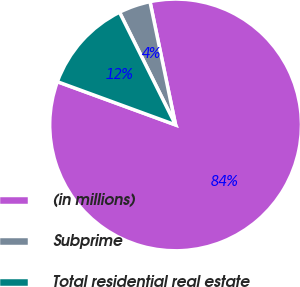Convert chart. <chart><loc_0><loc_0><loc_500><loc_500><pie_chart><fcel>(in millions)<fcel>Subprime<fcel>Total residential real estate<nl><fcel>83.84%<fcel>4.09%<fcel>12.07%<nl></chart> 